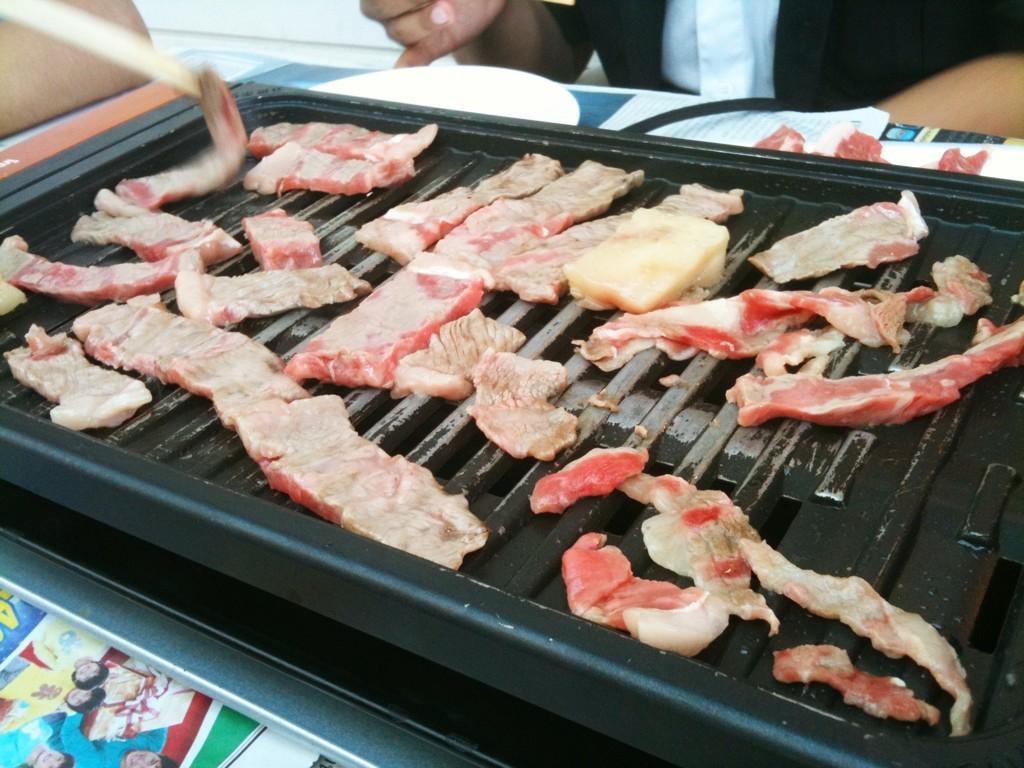Can you describe this image briefly? In this image, we can see a barbecue. There are few eatable things are placed on it. Top of the image, we can see a human hands, plate, wire, some papers. 